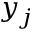Convert formula to latex. <formula><loc_0><loc_0><loc_500><loc_500>y _ { j }</formula> 